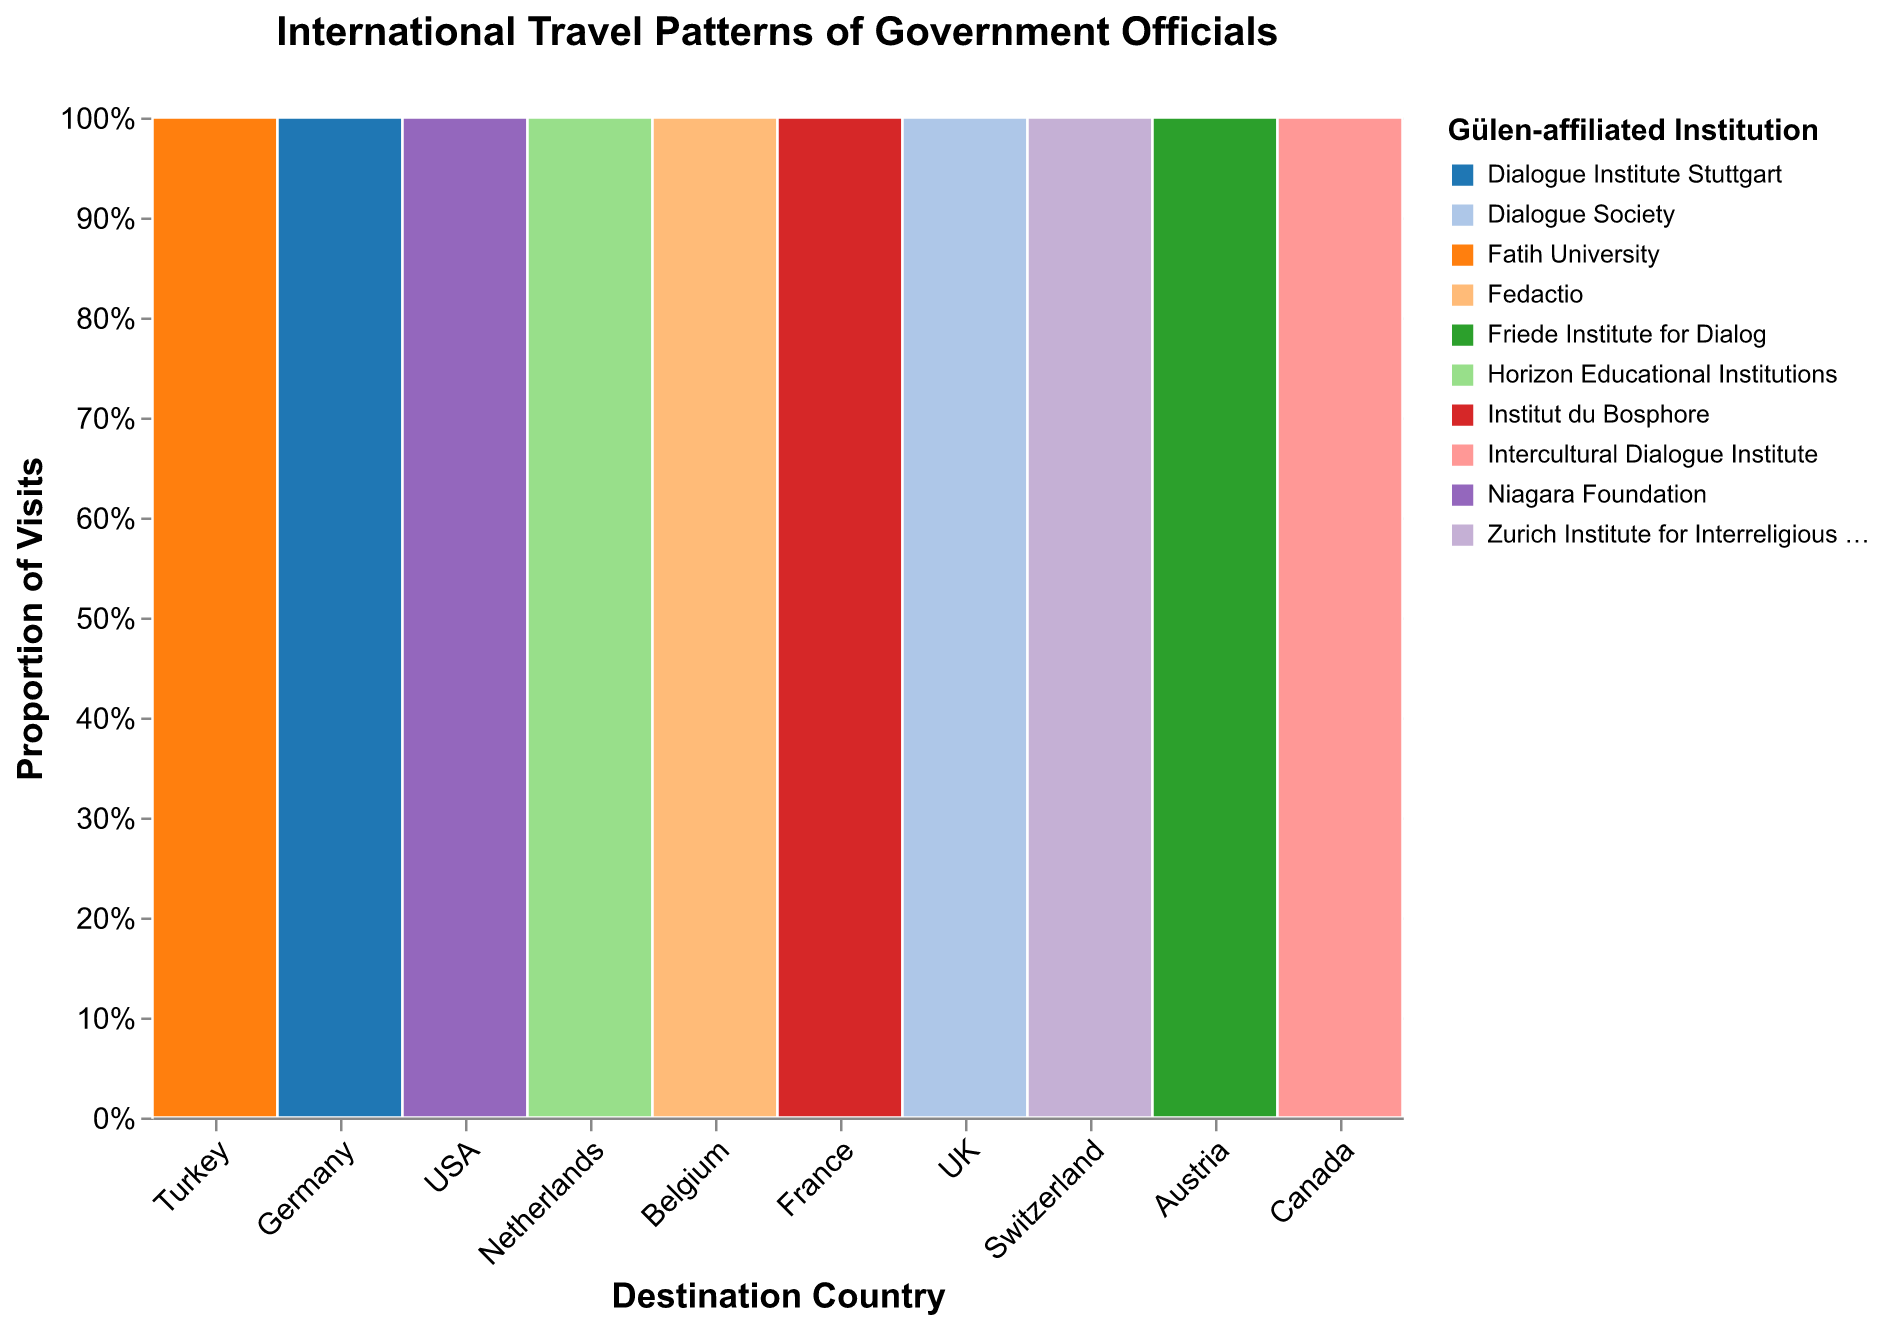What is the title of the figure? Look above the plot to find the title text: "International Travel Patterns of Government Officials"
Answer: International Travel Patterns of Government Officials Which country has the highest frequency of visits to Gülen-affiliated institutions? Examine the bars along the x-axis and find the bar with the greatest height. Turkey's bar is the tallest, indicating the highest frequency.
Answer: Turkey What are the Gülen-affiliated institutions visited in the USA? Look for the USA segment and identify the institution colors listed in the legend. The institution listed for USA is the Niagara Foundation.
Answer: Niagara Foundation Which country has the least frequent visits to Gülen-affiliated institutions? Find the shortest bar on the x-axis. Switzerland has the shortest bar, indicating the lowest frequency.
Answer: Switzerland How many more visits are there to Fatih University in Turkey compared to Dialogue Society in the UK? Turkey has 32 visits to Fatih University. The UK has 20 visits to the Dialogue Society. Subtract the visits to get the difference: 32 - 20 = 12.
Answer: 12 What proportion of the visits to Gülen-affiliated institutions in France are to the Institut du Bosphore? Find the proportion in the France segment by observing the y-axis labels or tooltip on hover: 100% since there is only one institution.
Answer: 100% Which countries have exactly one Gülen-affiliated institution with visits? Look for countries on the x-axis that have only one color representing an institution. The USA, France, and Switzerland each show only one institution.
Answer: USA, France, Switzerland Compare the frequency of visits to Gülen-affiliated institutions in Germany and Canada. Which has more? Germany has 18 visits, and Canada has 14 visits. Therefore, Germany has more visits than Canada.
Answer: Germany What is the total number of visits made to Gülen-affiliated institutions in European countries? Identify European countries (Germany, Netherlands, Belgium, France, UK, Switzerland, Austria) and sum their visits: 18 + 12 + 9 + 15 + 20 + 7 + 11 = 92.
Answer: 92 